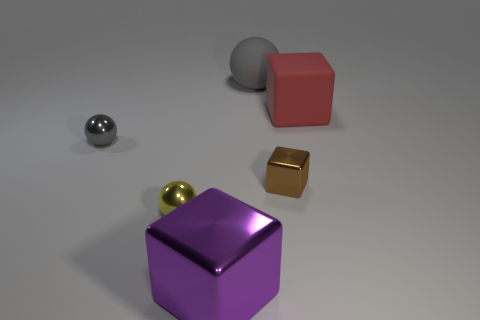Are there any other things that are the same size as the red cube?
Make the answer very short. Yes. Do the large metallic cube and the large sphere have the same color?
Offer a terse response. No. What is the color of the big cube behind the tiny ball in front of the small brown shiny cube?
Make the answer very short. Red. How many small objects are either red cubes or gray rubber things?
Your answer should be very brief. 0. What is the color of the cube that is both in front of the small gray shiny object and behind the purple metal object?
Your answer should be compact. Brown. Is the large gray thing made of the same material as the red block?
Give a very brief answer. Yes. The small gray metal object has what shape?
Offer a very short reply. Sphere. What number of gray metal spheres are in front of the small thing that is on the right side of the object that is in front of the yellow ball?
Provide a short and direct response. 0. There is a small object that is the same shape as the large purple metallic object; what is its color?
Provide a succinct answer. Brown. What is the shape of the gray object that is on the left side of the gray object to the right of the tiny ball that is behind the brown thing?
Offer a terse response. Sphere. 